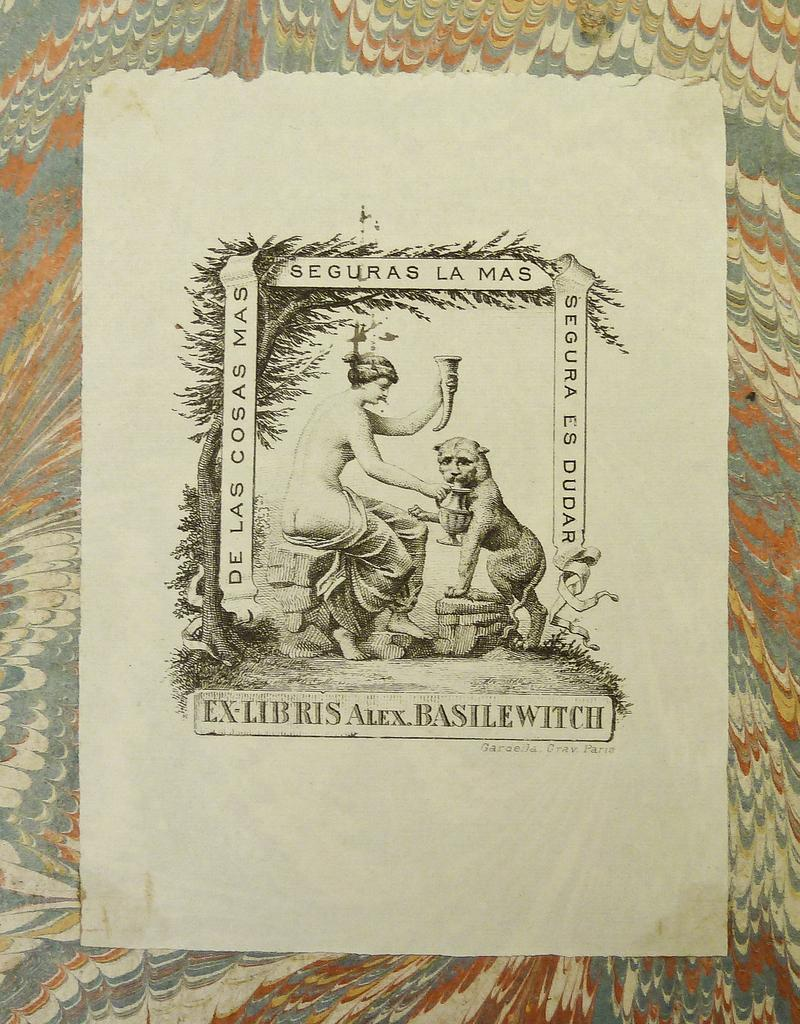<image>
Give a short and clear explanation of the subsequent image. A black and white drawing of a woman and a leopard by Alex Bastlewitch. 